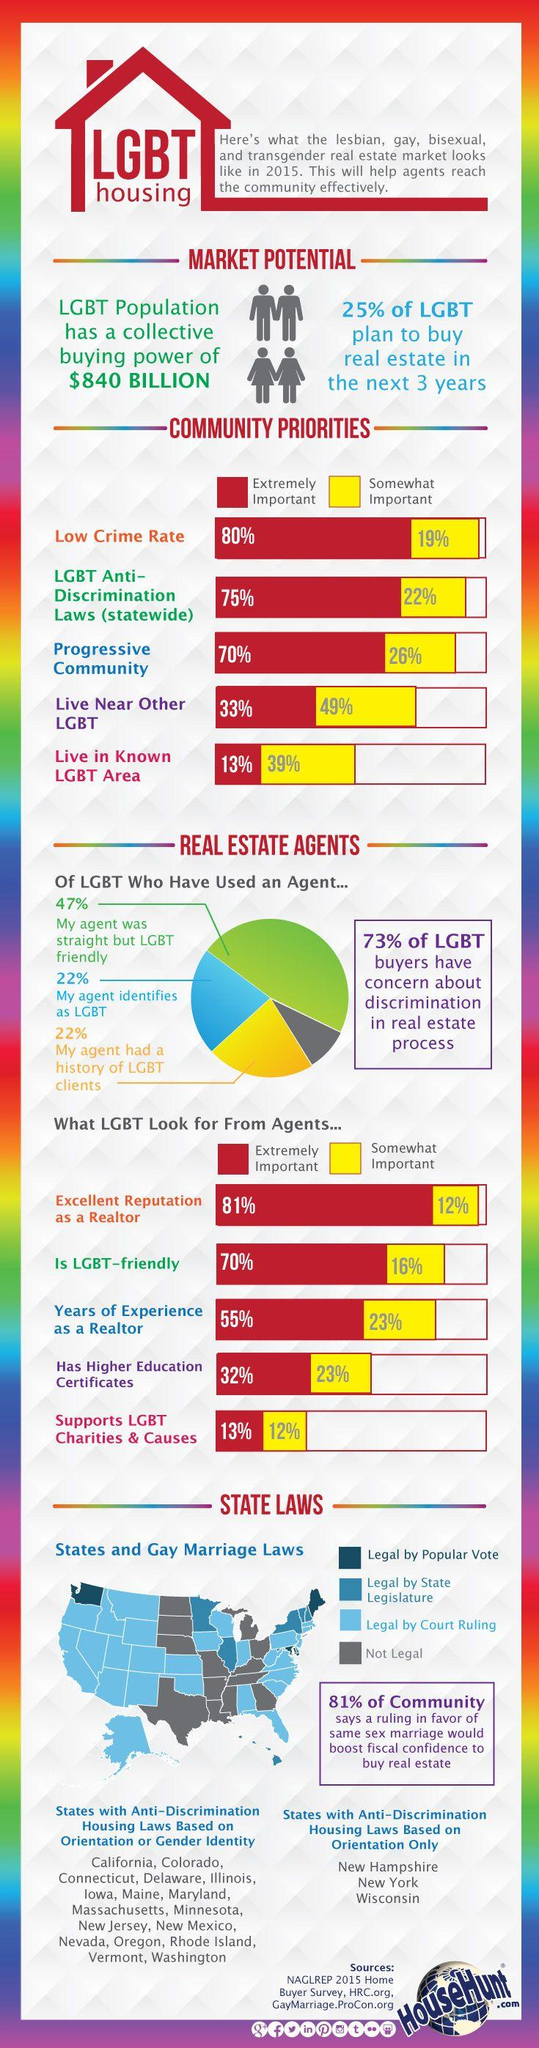Give some essential details in this illustration. According to a survey, 23% of LGBT individuals believe that it is important for their real estate agent to have higher education certificates. There are currently 3 states that have anti-discrimination housing laws based solely on a person's sexual orientation. According to the survey, 49% of respondents consider having a strong LGBT community nearby to be an important priority. According to a study of LGBT individuals who have used a real estate agent, 22% found that their agent was also LGBT. 